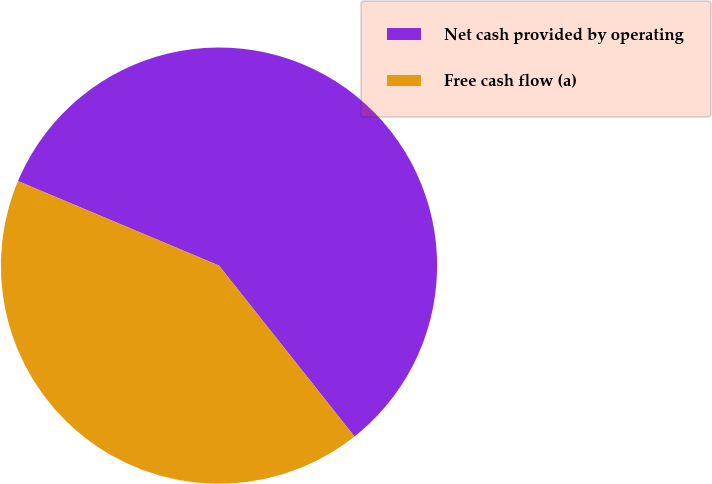Convert chart. <chart><loc_0><loc_0><loc_500><loc_500><pie_chart><fcel>Net cash provided by operating<fcel>Free cash flow (a)<nl><fcel>58.0%<fcel>42.0%<nl></chart> 